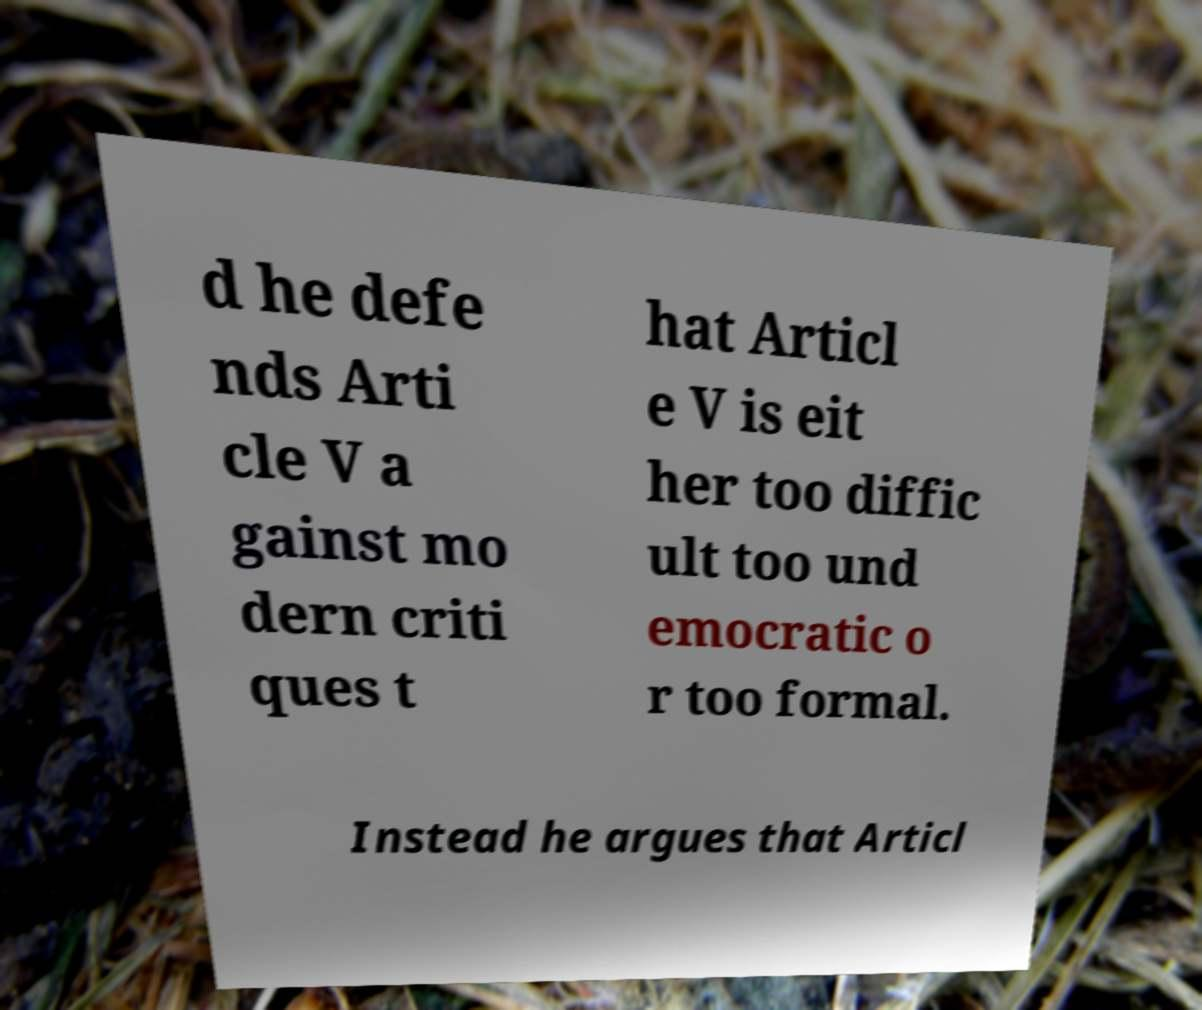Could you assist in decoding the text presented in this image and type it out clearly? d he defe nds Arti cle V a gainst mo dern criti ques t hat Articl e V is eit her too diffic ult too und emocratic o r too formal. Instead he argues that Articl 